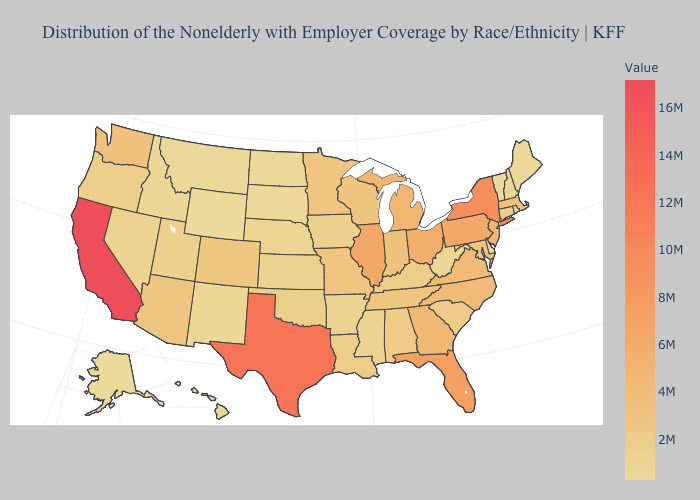Does the map have missing data?
Concise answer only. No. Which states hav the highest value in the South?
Give a very brief answer. Texas. Does the map have missing data?
Answer briefly. No. 